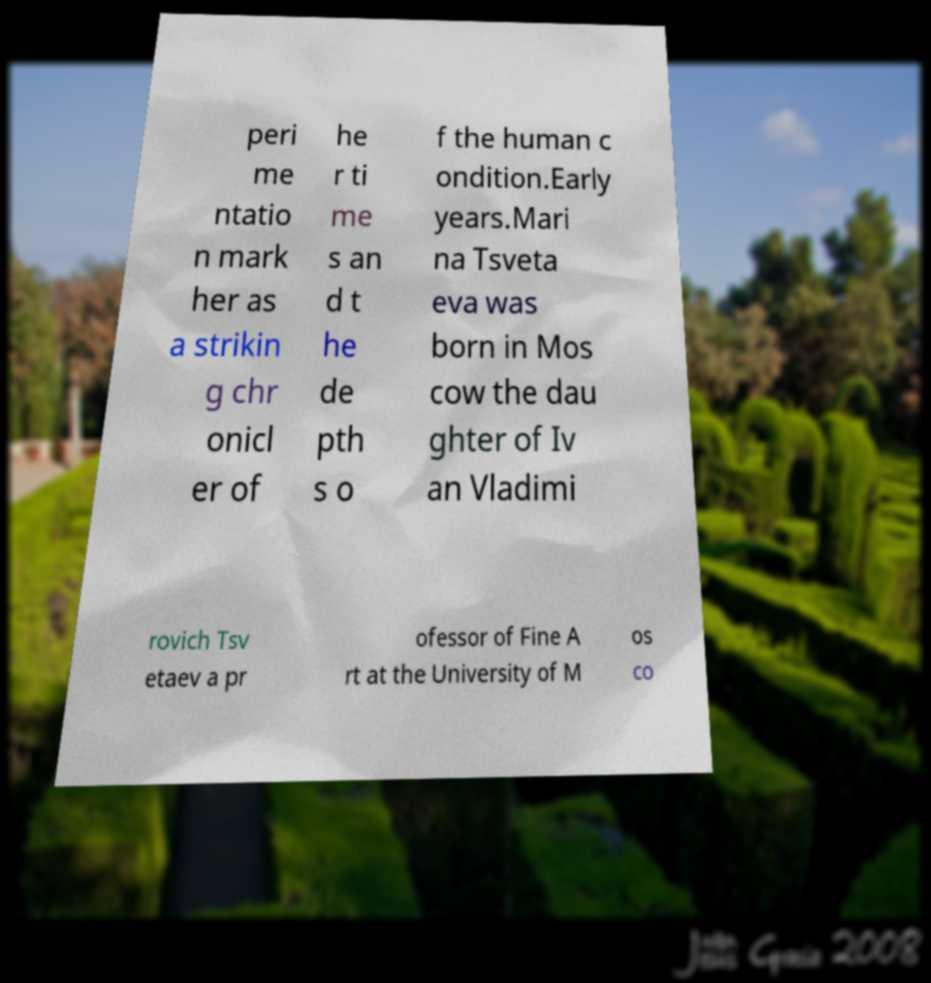Please identify and transcribe the text found in this image. peri me ntatio n mark her as a strikin g chr onicl er of he r ti me s an d t he de pth s o f the human c ondition.Early years.Mari na Tsveta eva was born in Mos cow the dau ghter of Iv an Vladimi rovich Tsv etaev a pr ofessor of Fine A rt at the University of M os co 